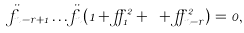Convert formula to latex. <formula><loc_0><loc_0><loc_500><loc_500>\ddot { f } _ { n - r + 1 } \dots \ddot { f } _ { n } ( 1 + \alpha _ { 1 } ^ { 2 } + \cdots + \alpha _ { n - r } ^ { 2 } ) = 0 ,</formula> 